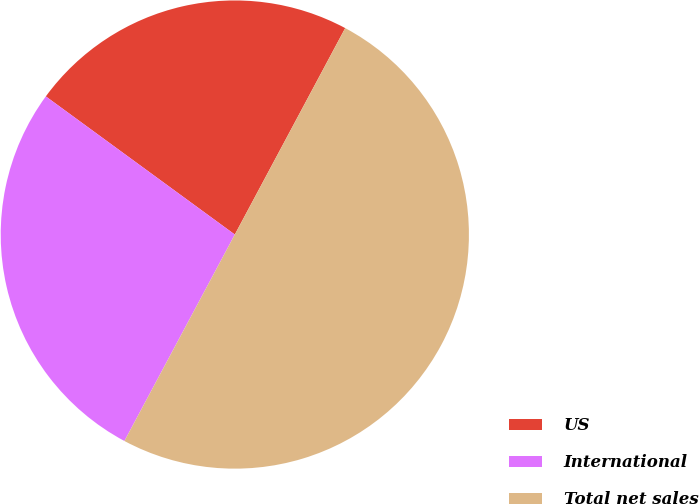<chart> <loc_0><loc_0><loc_500><loc_500><pie_chart><fcel>US<fcel>International<fcel>Total net sales<nl><fcel>22.77%<fcel>27.23%<fcel>50.0%<nl></chart> 